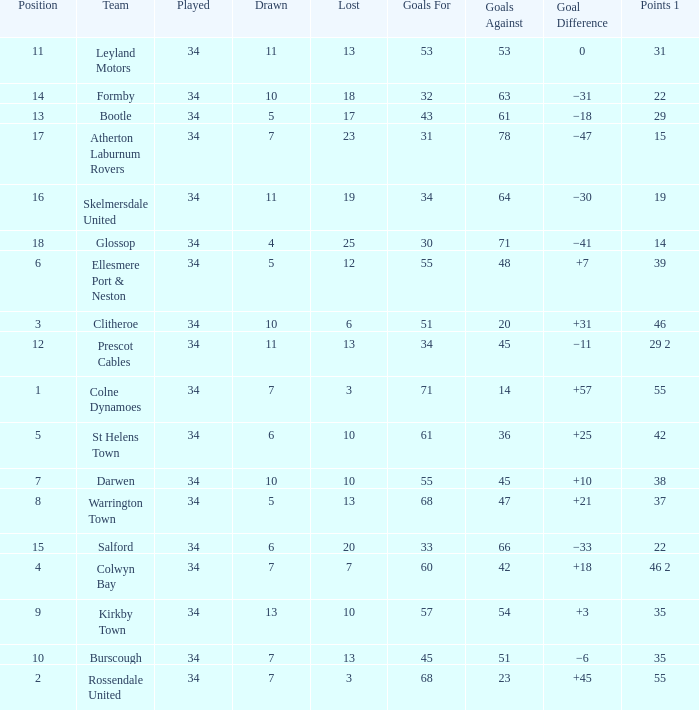Which Position has 47 Goals Against, and a Played larger than 34? None. 